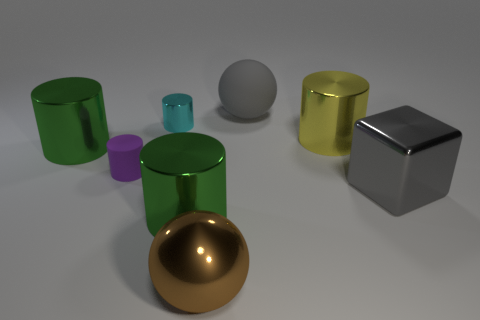Do the matte sphere and the metallic cylinder that is on the right side of the brown object have the same size?
Your answer should be very brief. Yes. How many objects are either cylinders behind the gray block or big green shiny things in front of the large metal block?
Your response must be concise. 5. What shape is the rubber thing that is the same size as the yellow metallic cylinder?
Give a very brief answer. Sphere. What is the shape of the gray thing that is behind the big gray object in front of the gray matte object that is to the left of the yellow thing?
Offer a very short reply. Sphere. Are there the same number of cyan objects in front of the brown metal ball and rubber blocks?
Keep it short and to the point. Yes. Do the rubber cylinder and the brown ball have the same size?
Keep it short and to the point. No. How many rubber things are large green spheres or gray things?
Your response must be concise. 1. What material is the cyan thing that is the same size as the rubber cylinder?
Provide a short and direct response. Metal. What number of other things are the same material as the big cube?
Make the answer very short. 5. Is the number of gray cubes to the left of the gray shiny block less than the number of small purple rubber cylinders?
Provide a short and direct response. Yes. 